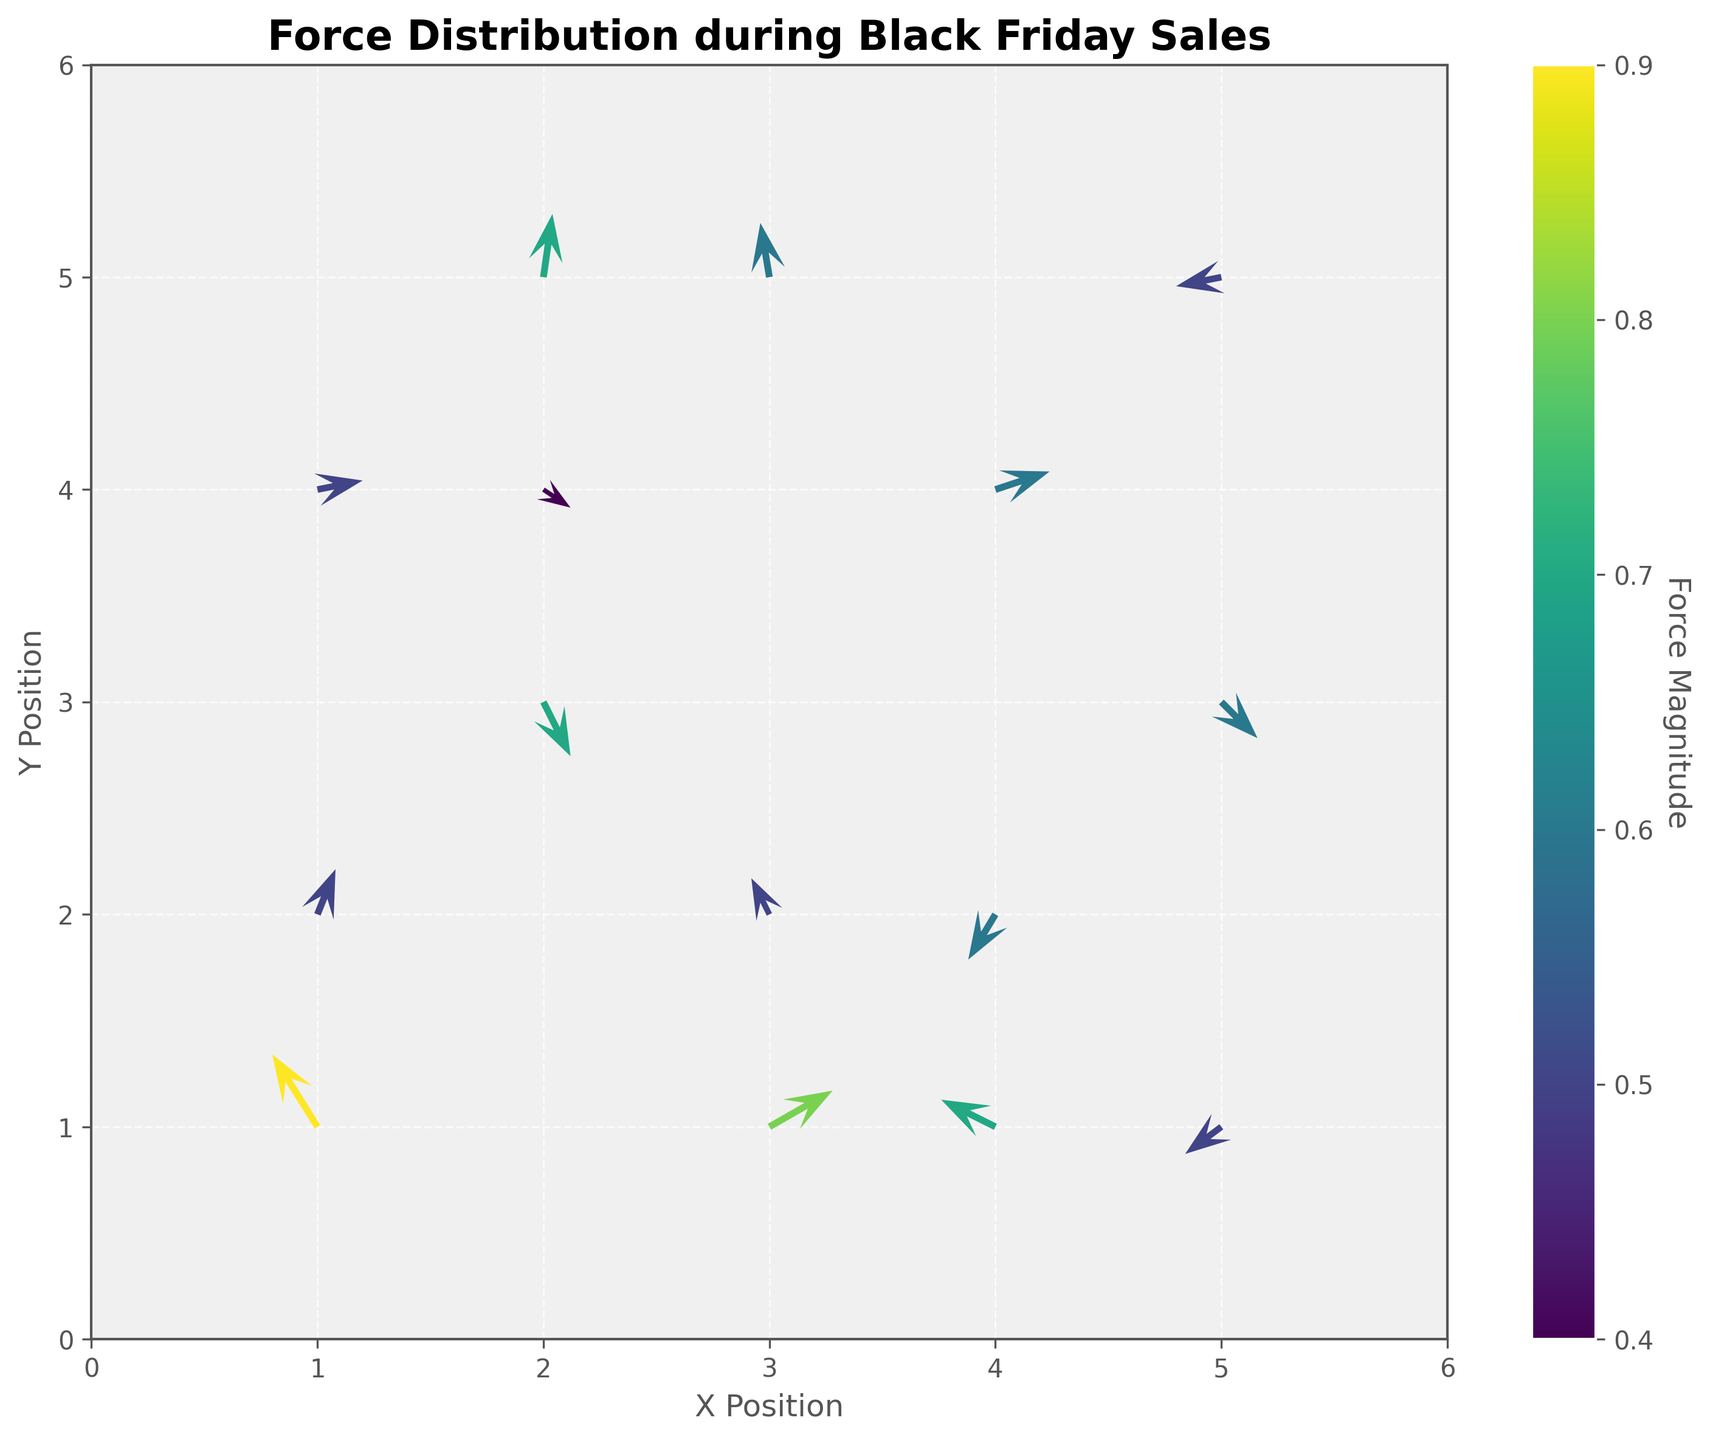What is the title of the plot? The title is usually displayed at the top of the figure in a bold, larger font to give an overview of what the plot represents. Here, it's specifically about the distribution of forces during a specific event.
Answer: Force Distribution during Black Friday Sales What are the labels of the x and y axes? The labels of the axes provide information about what each dimension of the plot represents. They are positioned along each axis and typically have a clear, descriptive text.
Answer: X Position and Y Position How many data points are represented in the plot? Data points are usually displayed as the origin points of the arrows in a quiver plot. Each matches a pair of coordinates with direction vectors. Count each unique origin point to find the total.
Answer: 15 What is the range of force magnitudes represented in the color bar? The range can be observed from the color bar, which provides a visual scale for interpreting the magnitude of forces represented by different colors. The minimum and maximum values on the color bar will give this range.
Answer: 0.4 to 0.9 Which data point has the largest force magnitude? The largest force magnitude can be identified by looking at the color bar and finding which arrow has the color that corresponds to the highest value in the range.
Answer: (1,1) What direction is the force at (5, 3)? Look at the arrow emanating from the coordinates (5, 3). The direction of the arrow indicates the force's direction. Note that the tail is at (5, 3), and the head points in the force's direction.
Answer: Down-left or southwest Which position has a force direction pointing upwards? Inspect the direction of each arrow to determine which one(s) point upwards. The tail of the arrow will provide the position.
Answer: (1,1), (1,2), (2,5), (3,5) What is the average force magnitude across all data points? To find the average force magnitude, sum up all the magnitudes of each data point and then divide by the total number of data points. The given magnitudes need to be summed and averaged. The calculation: (0.9 + 0.7 + 0.5 + 0.6 + 0.5 + 0.7 + 0.6 + 0.5 + 0.6 + 0.6 + 0.5 + 0.7 + 0.4 + 0.5 + 0.8) / 15 = 0.6
Answer: 0.6 